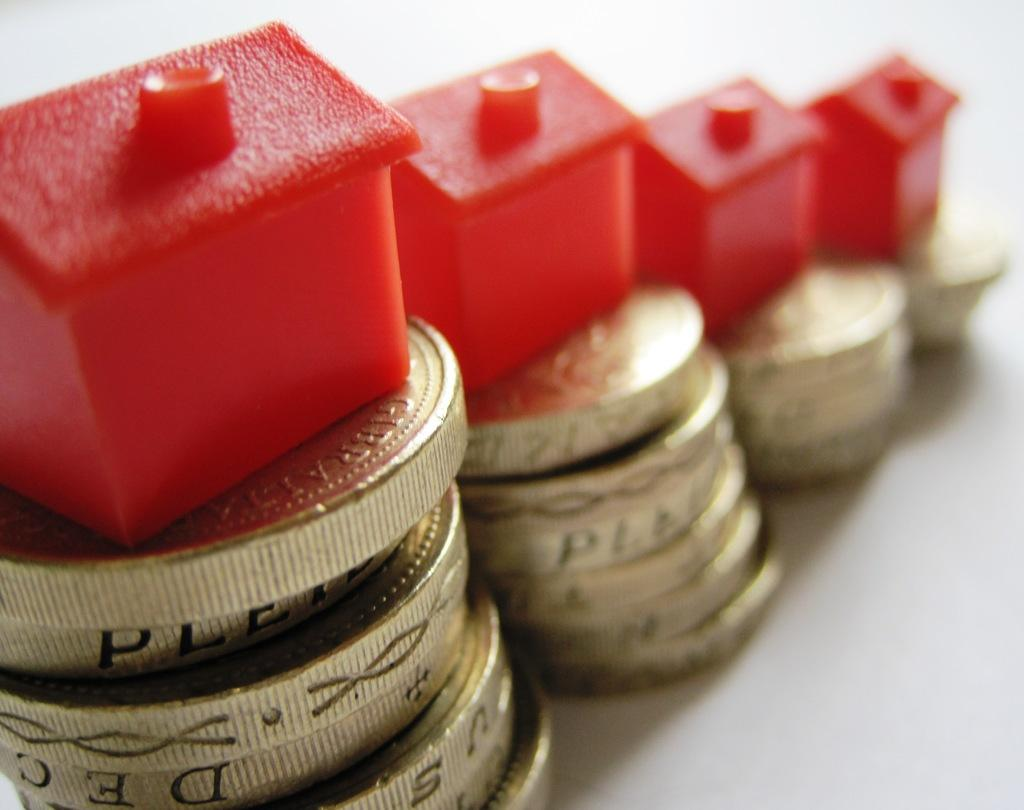What color are the toys in the image? The toys in the image are red. What are the red toys placed on? The red toys are placed on coins. What is the color of the surface on which the red toys and coins are placed? The red toys and coins are placed on a white surface. What type of bottle is placed next to the red toys in the image? There is no bottle present in the image. 